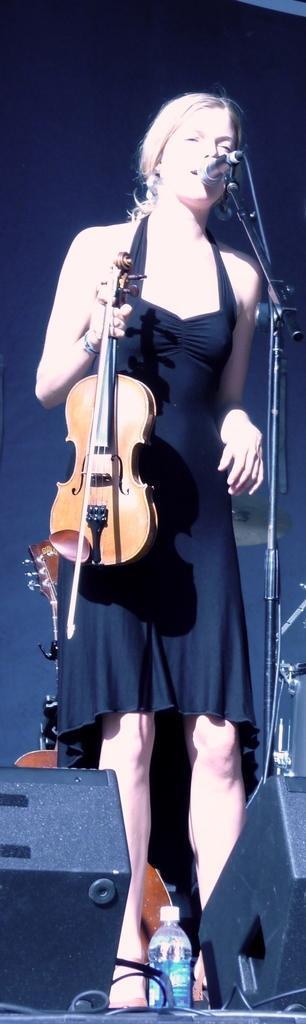Please provide a concise description of this image. In the image we can see there is a woman who is standing and holding violin in her hand and in front of her there is mic with the stand and on the ground there is water bottle and there are speakers. 